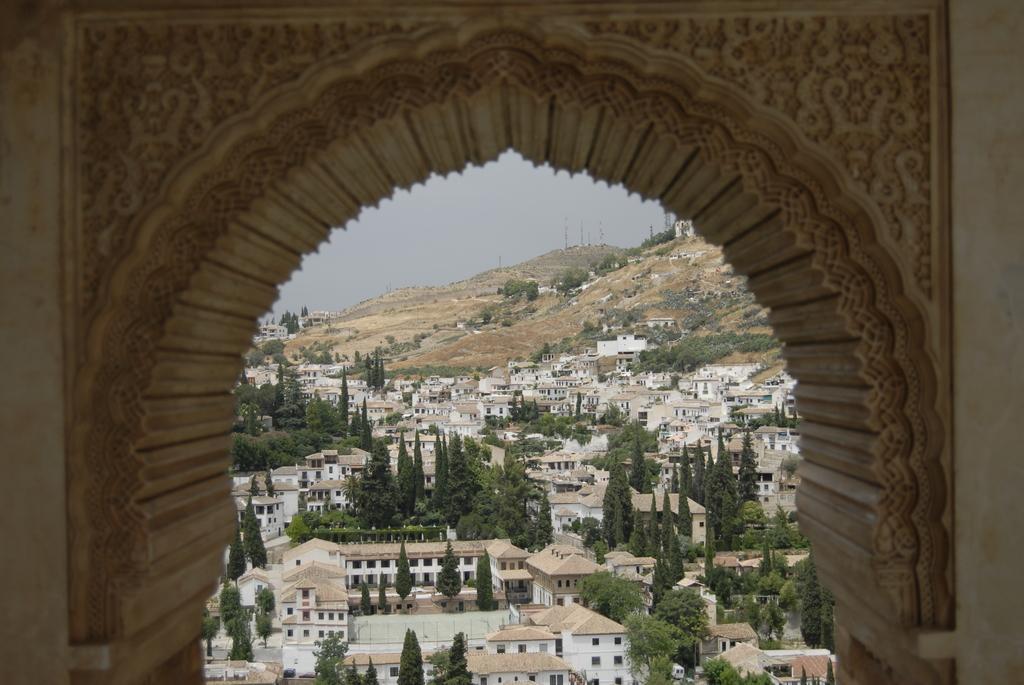Could you give a brief overview of what you see in this image? In this image we can see a wall with carvings. There are houses, trees. In the background of the image there is sky and mountain. 